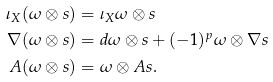<formula> <loc_0><loc_0><loc_500><loc_500>\iota _ { X } ( \omega \otimes s ) & = \iota _ { X } \omega \otimes s \\ \nabla ( \omega \otimes s ) & = d \omega \otimes s + ( - 1 ) ^ { p } \omega \otimes \nabla s \\ A ( \omega \otimes s ) & = \omega \otimes A s .</formula> 